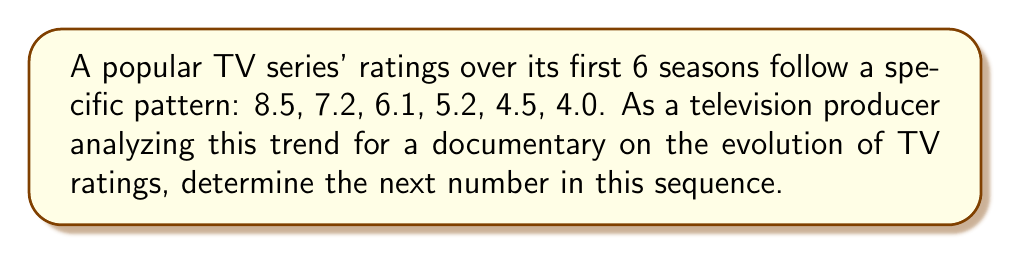Solve this math problem. To solve this problem, let's analyze the pattern in the given sequence:

1) First, calculate the differences between consecutive terms:
   8.5 to 7.2: decrease of 1.3
   7.2 to 6.1: decrease of 1.1
   6.1 to 5.2: decrease of 0.9
   5.2 to 4.5: decrease of 0.7
   4.5 to 4.0: decrease of 0.5

2) We can see that the difference itself is decreasing by 0.2 each time:
   1.3 - 1.1 = 0.2
   1.1 - 0.9 = 0.2
   0.9 - 0.7 = 0.2
   0.7 - 0.5 = 0.2

3) This suggests that the sequence follows a quadratic pattern.

4) To find the next term, we need to decrease 4.0 by the next difference in the pattern.

5) The next difference would be 0.5 - 0.2 = 0.3

6) Therefore, the next term in the sequence would be:
   4.0 - 0.3 = 3.7

The formula for this quadratic sequence can be expressed as:

$$a_n = 8.5 - 1.5n + 0.1n^2$$

Where $n$ is the term number (starting from 0 for the first term).
Answer: 3.7 